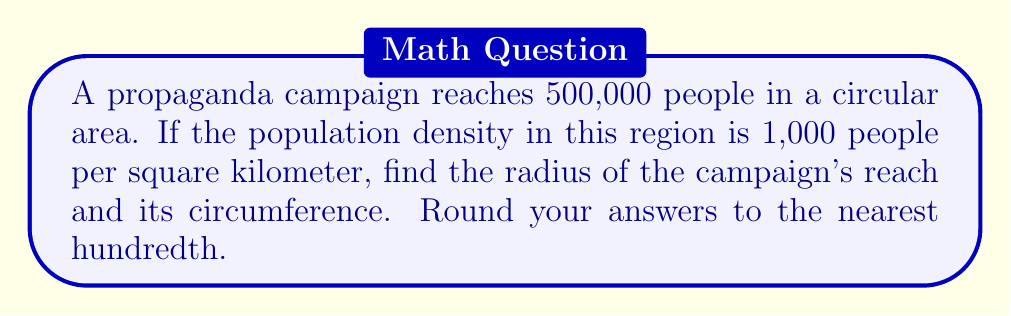What is the answer to this math problem? To solve this problem, we'll follow these steps:

1) First, let's find the area of the circular region:
   $$\text{Area} = \frac{\text{Number of people}}{\text{Population density}}$$
   $$\text{Area} = \frac{500,000}{1,000} = 500 \text{ km}^2$$

2) Now, we can use the formula for the area of a circle to find the radius:
   $$A = \pi r^2$$
   $$500 = \pi r^2$$

3) Solve for r:
   $$r^2 = \frac{500}{\pi}$$
   $$r = \sqrt{\frac{500}{\pi}} \approx 12.62 \text{ km}$$

4) To find the circumference, we use the formula:
   $$C = 2\pi r$$
   $$C = 2\pi(12.62) \approx 79.27 \text{ km}$$

[asy]
import geometry;

size(200);
pair O = (0,0);
real r = 5;
draw(circle(O, r), blue);
draw(O--(-r,0), arrow=Arrow(TeXHead));
label("12.62 km", (-r/2,0), S);
draw(Arc(O, (r,0), 180), arrow=Arrow(TeXHead), red);
label("79.27 km", (0,r+0.5), N, red);
</asy]

This diagram illustrates the circular reach of the propaganda campaign, with the radius and circumference labeled.
Answer: Radius: 12.62 km, Circumference: 79.27 km 